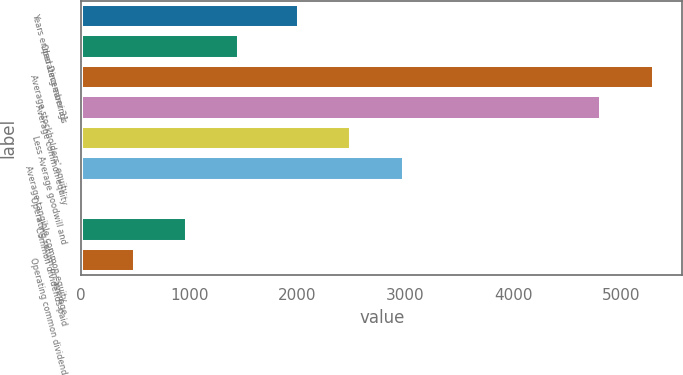<chart> <loc_0><loc_0><loc_500><loc_500><bar_chart><fcel>Years ended December 31<fcel>Operating earnings<fcel>Average stockholders' equity<fcel>Average common equity<fcel>Less Average goodwill and<fcel>Average tangible common equity<fcel>Operating return on average<fcel>Common dividends paid<fcel>Operating common dividend<nl><fcel>2016<fcel>1464.91<fcel>5302.87<fcel>4818<fcel>2500.87<fcel>2985.74<fcel>10.3<fcel>980.04<fcel>495.17<nl></chart> 